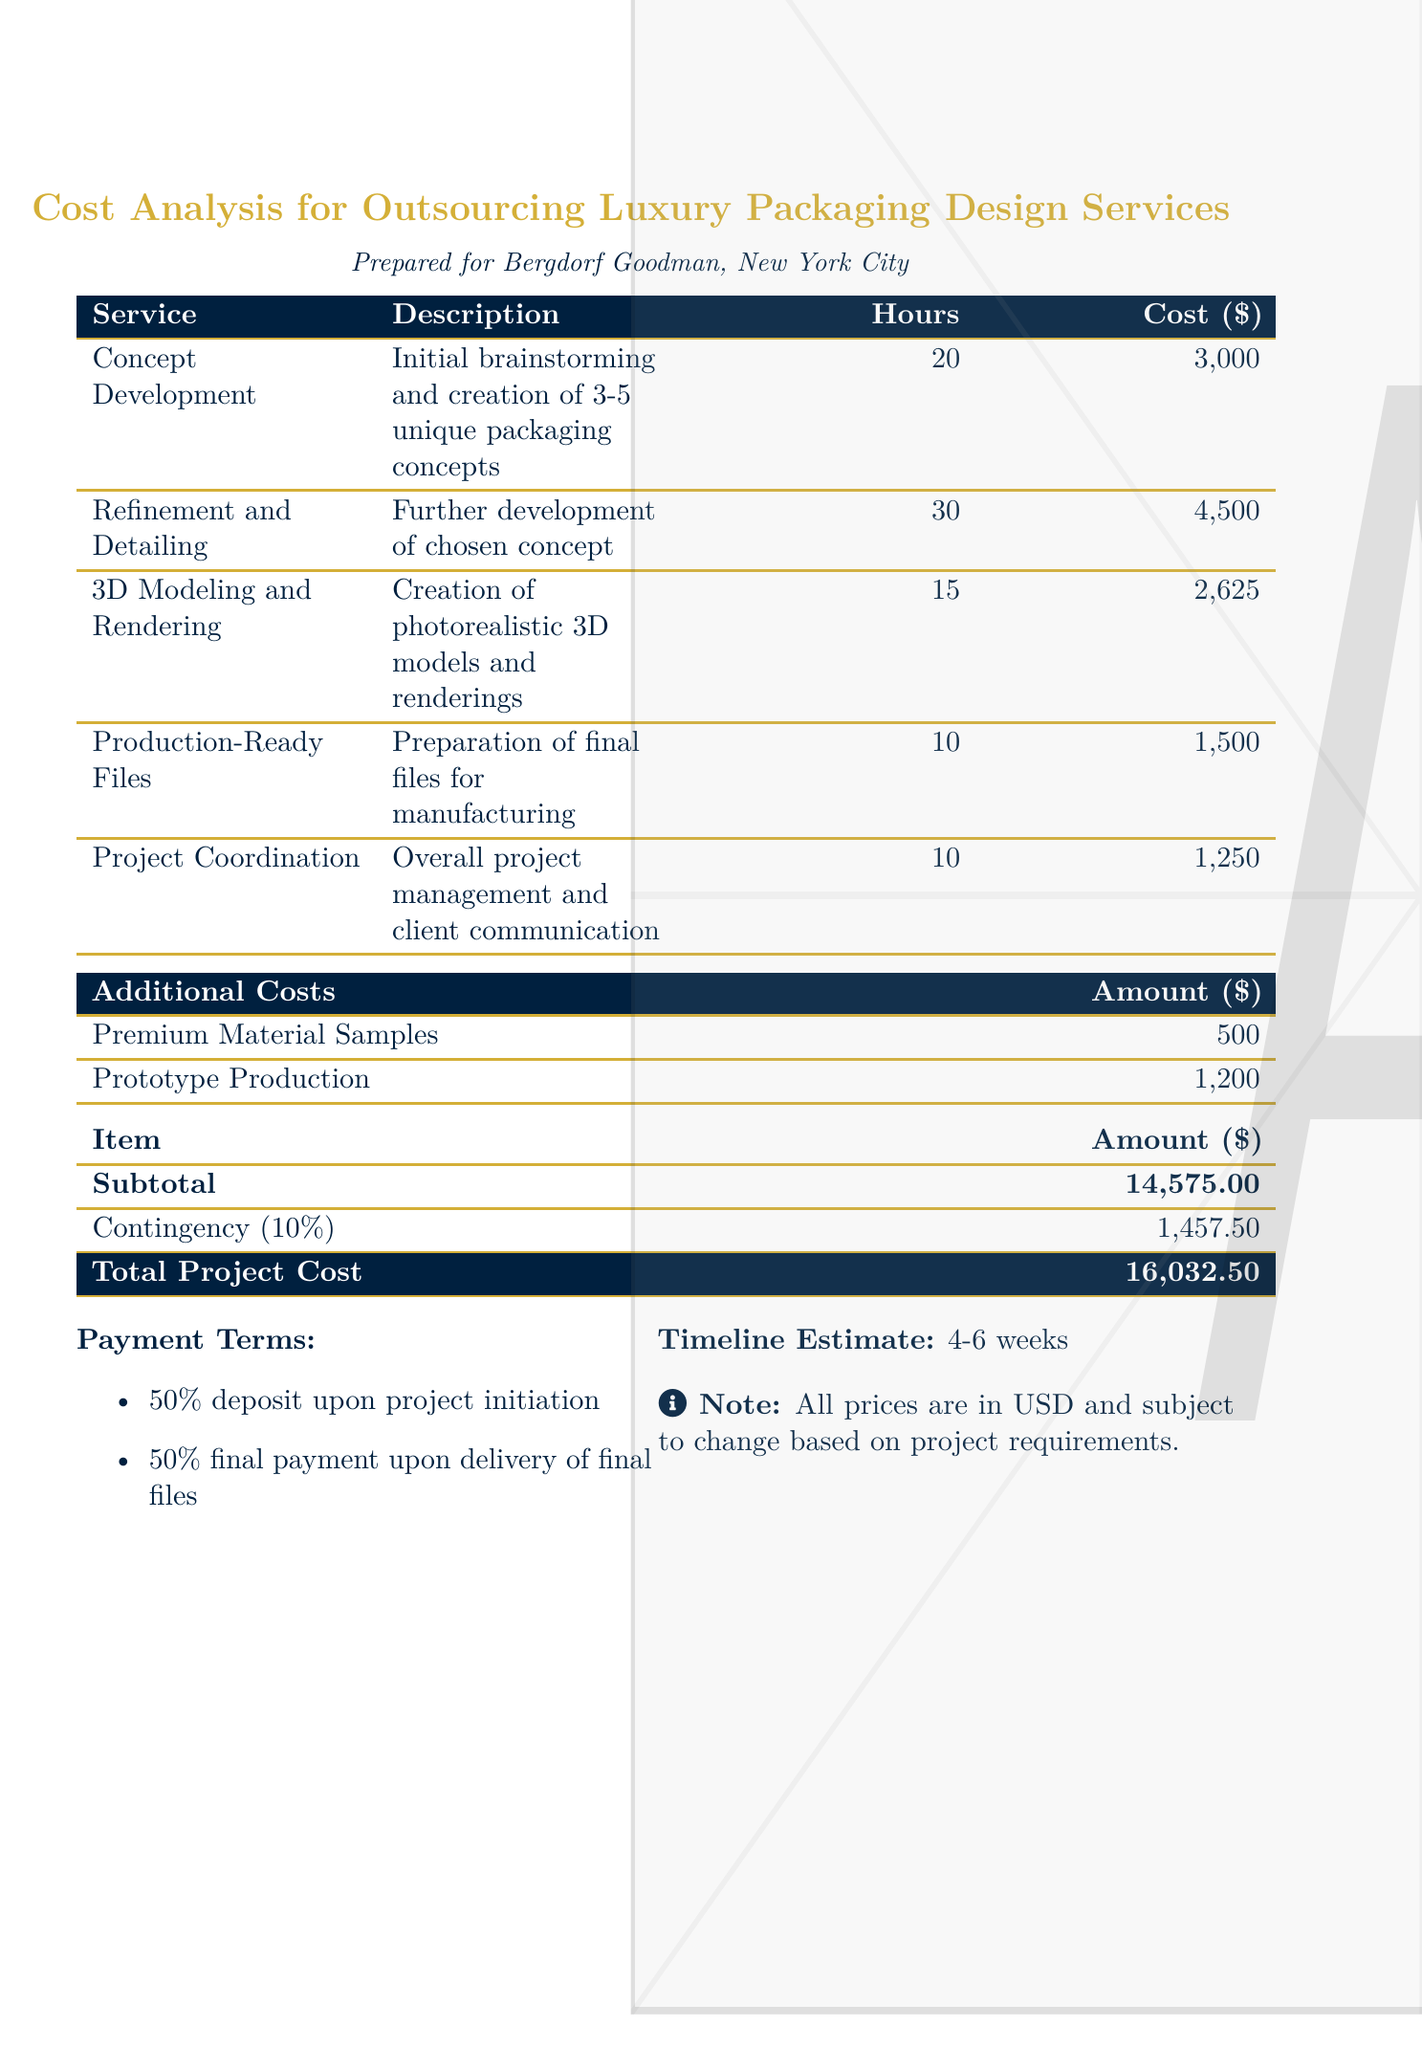What is the total project cost? The total project cost is directly stated in the summary section of the document.
Answer: 16,032.50 How many hours are allocated for refinement and detailing? The number of hours for refinement and detailing is specified in the service breakdown.
Answer: 30 What is the cost for production-ready files? The cost for production-ready files can be found in the cost breakdown of services.
Answer: 1,500 What percentage is added for contingency? The contingency percentage is noted in the summary section and is used to calculate the total project cost.
Answer: 10% What is the payment term for the final payment? The payment terms outline the conditions for the final payment which can be found in the document.
Answer: 50% final payment upon delivery of final files How much is allocated for premium material samples? The allocation for premium material samples is listed under additional costs in the document.
Answer: 500 What is the first step in the service description? The initial service in the description section tells what the first step involves for the packaging design process.
Answer: Initial brainstorming and creation of 3-5 unique packaging concepts How long is the estimated timeline for project completion? The timeline estimate section mentions the duration expected for the project.
Answer: 4-6 weeks How many unique packaging concepts are created in the concept development phase? The number of unique concepts developed is stated in the concept development service description.
Answer: 3-5 